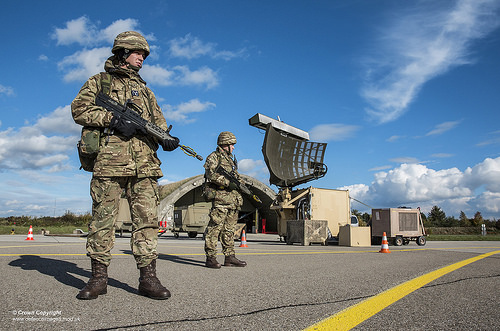<image>
Is there a machine gun on the soldier? Yes. Looking at the image, I can see the machine gun is positioned on top of the soldier, with the soldier providing support. Is the soldier in front of the cone? Yes. The soldier is positioned in front of the cone, appearing closer to the camera viewpoint. Is the helmet in front of the symbole? No. The helmet is not in front of the symbole. The spatial positioning shows a different relationship between these objects. 